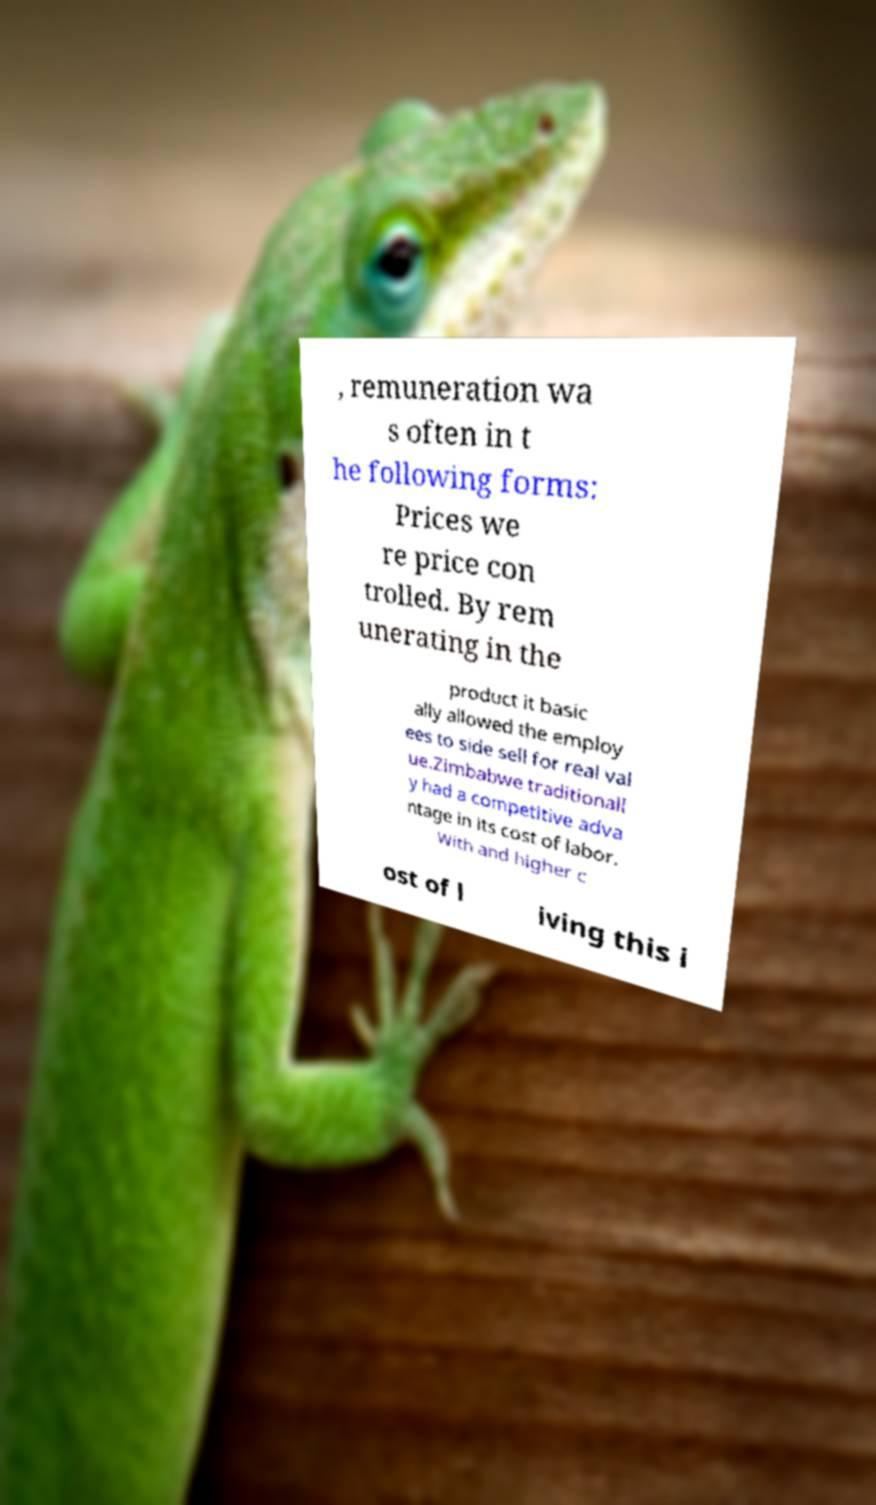Could you assist in decoding the text presented in this image and type it out clearly? , remuneration wa s often in t he following forms: Prices we re price con trolled. By rem unerating in the product it basic ally allowed the employ ees to side sell for real val ue.Zimbabwe traditionall y had a competitive adva ntage in its cost of labor. With and higher c ost of l iving this i 